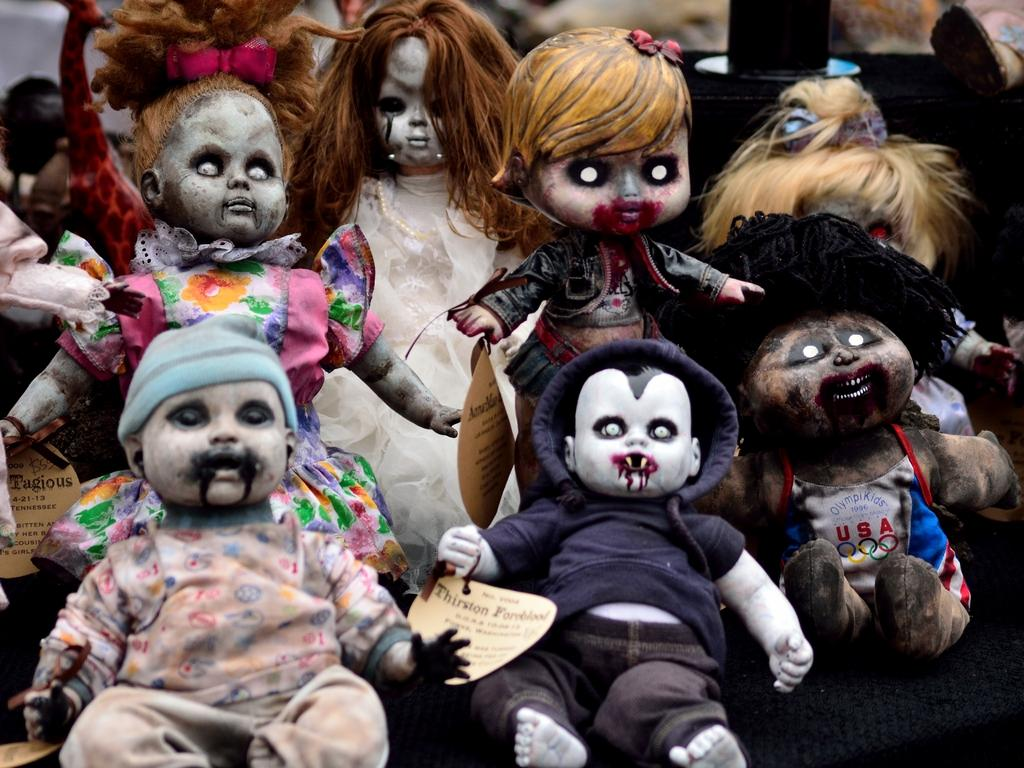What is the main subject of the image? There is a group of dolls in the image. Can you describe one of the dolls in the group? One of the dolls is wearing a blue coat. What can be seen in the background of the image? There is a pole in the background of the image. What are the dolls writing in the image? There is no indication in the image that the dolls are writing anything. How many brothers are present in the image? There is no mention of any brothers in the image; it features a group of dolls. 